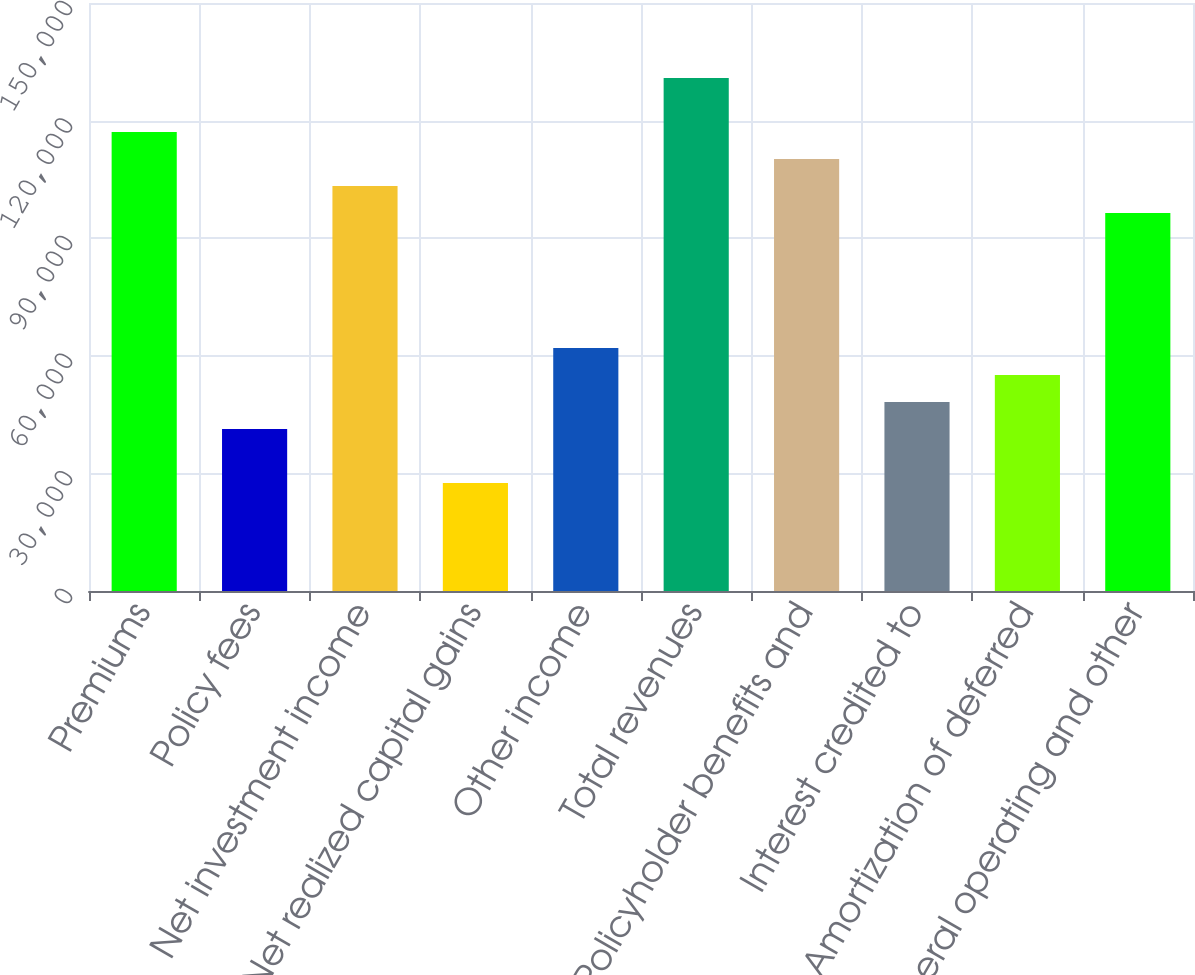Convert chart to OTSL. <chart><loc_0><loc_0><loc_500><loc_500><bar_chart><fcel>Premiums<fcel>Policy fees<fcel>Net investment income<fcel>Net realized capital gains<fcel>Other income<fcel>Total revenues<fcel>Policyholder benefits and<fcel>Interest credited to<fcel>Amortization of deferred<fcel>General operating and other<nl><fcel>117081<fcel>41327.2<fcel>103308<fcel>27553.8<fcel>61987.3<fcel>130854<fcel>110194<fcel>48213.9<fcel>55100.6<fcel>96420.8<nl></chart> 